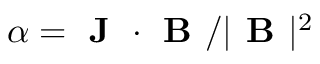Convert formula to latex. <formula><loc_0><loc_0><loc_500><loc_500>\alpha = J \cdot B / | B | ^ { 2 }</formula> 